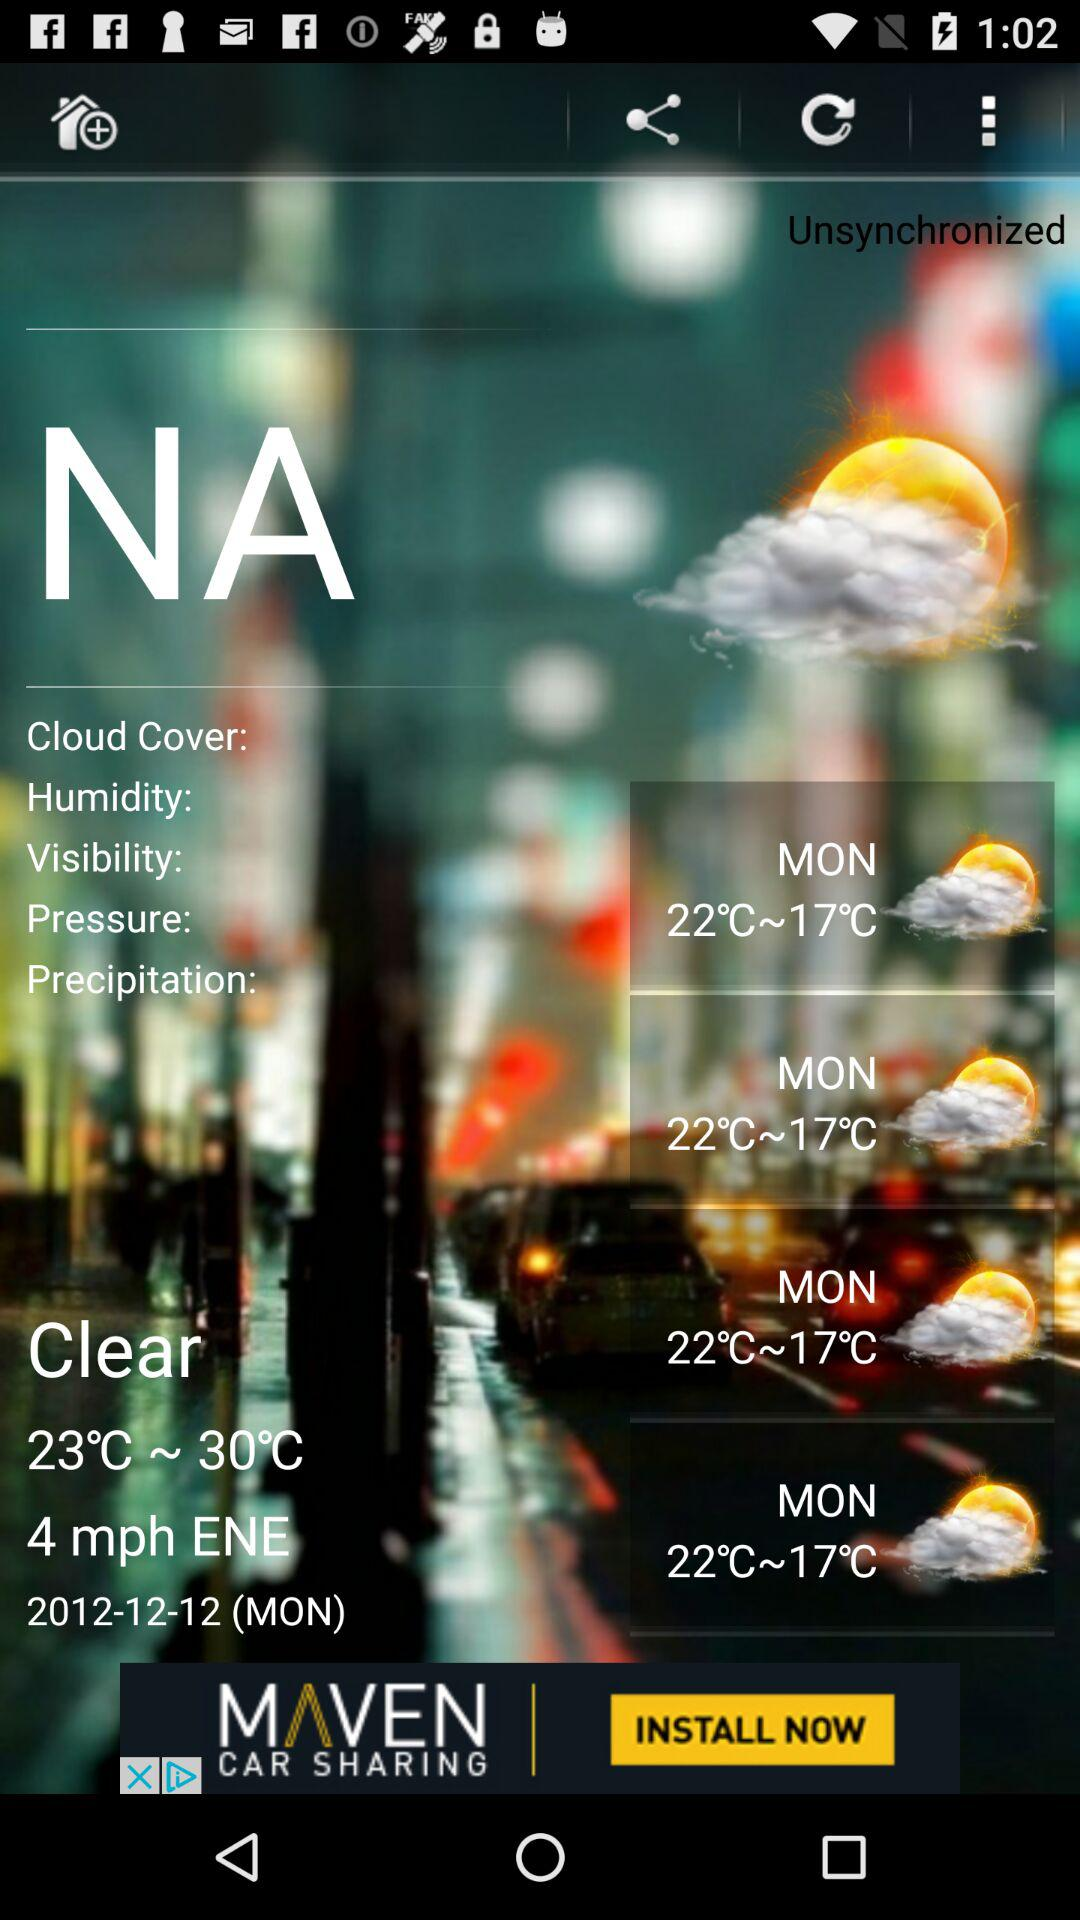On which date is Monday? Monday is on December 12, 2012. 